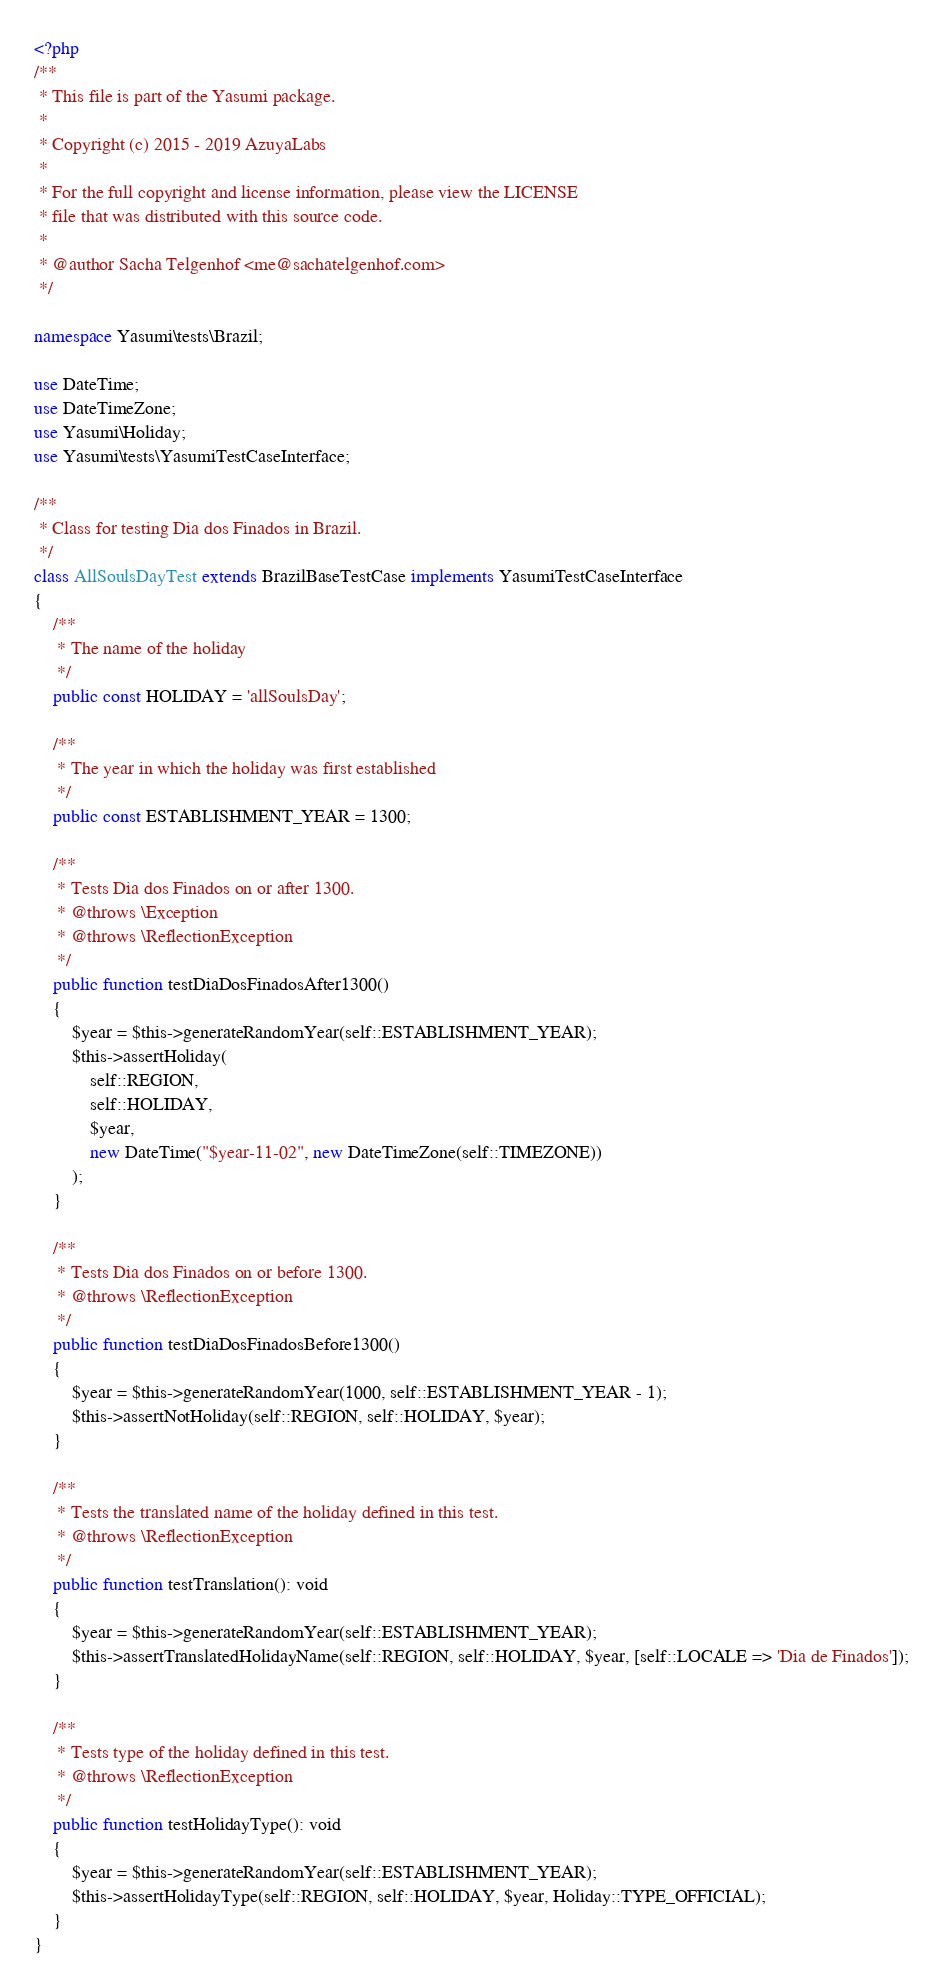<code> <loc_0><loc_0><loc_500><loc_500><_PHP_><?php
/**
 * This file is part of the Yasumi package.
 *
 * Copyright (c) 2015 - 2019 AzuyaLabs
 *
 * For the full copyright and license information, please view the LICENSE
 * file that was distributed with this source code.
 *
 * @author Sacha Telgenhof <me@sachatelgenhof.com>
 */

namespace Yasumi\tests\Brazil;

use DateTime;
use DateTimeZone;
use Yasumi\Holiday;
use Yasumi\tests\YasumiTestCaseInterface;

/**
 * Class for testing Dia dos Finados in Brazil.
 */
class AllSoulsDayTest extends BrazilBaseTestCase implements YasumiTestCaseInterface
{
    /**
     * The name of the holiday
     */
    public const HOLIDAY = 'allSoulsDay';

    /**
     * The year in which the holiday was first established
     */
    public const ESTABLISHMENT_YEAR = 1300;

    /**
     * Tests Dia dos Finados on or after 1300.
     * @throws \Exception
     * @throws \ReflectionException
     */
    public function testDiaDosFinadosAfter1300()
    {
        $year = $this->generateRandomYear(self::ESTABLISHMENT_YEAR);
        $this->assertHoliday(
            self::REGION,
            self::HOLIDAY,
            $year,
            new DateTime("$year-11-02", new DateTimeZone(self::TIMEZONE))
        );
    }

    /**
     * Tests Dia dos Finados on or before 1300.
     * @throws \ReflectionException
     */
    public function testDiaDosFinadosBefore1300()
    {
        $year = $this->generateRandomYear(1000, self::ESTABLISHMENT_YEAR - 1);
        $this->assertNotHoliday(self::REGION, self::HOLIDAY, $year);
    }

    /**
     * Tests the translated name of the holiday defined in this test.
     * @throws \ReflectionException
     */
    public function testTranslation(): void
    {
        $year = $this->generateRandomYear(self::ESTABLISHMENT_YEAR);
        $this->assertTranslatedHolidayName(self::REGION, self::HOLIDAY, $year, [self::LOCALE => 'Dia de Finados']);
    }

    /**
     * Tests type of the holiday defined in this test.
     * @throws \ReflectionException
     */
    public function testHolidayType(): void
    {
        $year = $this->generateRandomYear(self::ESTABLISHMENT_YEAR);
        $this->assertHolidayType(self::REGION, self::HOLIDAY, $year, Holiday::TYPE_OFFICIAL);
    }
}
</code> 